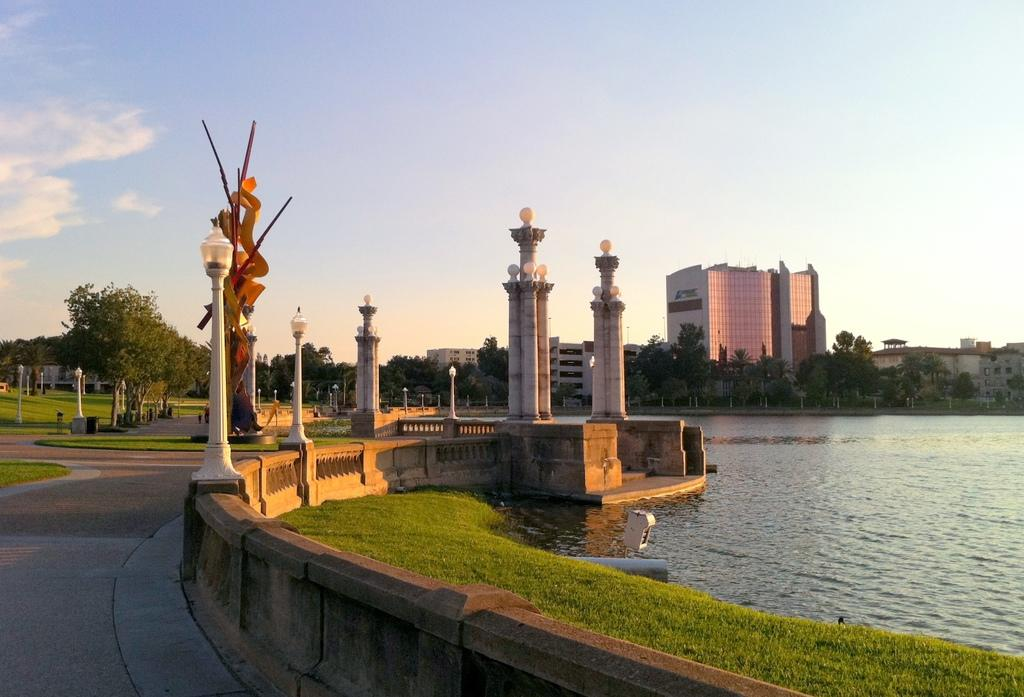What type of structures can be seen in the image? There are buildings in the image. What natural elements are present in the image? There are trees and grass on the ground in the image. What artificial elements are present in the image? There are poles with lights in the image. What type of surface is visible in the image? There is water visible in the image. How would you describe the sky in the image? The sky is blue and cloudy in the image. What additional feature can be found in the image? There is a statue in the image. How many buttons can be seen on the statue in the image? There are no buttons present on the statue in the image. What type of snails can be seen crawling on the grass in the image? There are no snails present in the image. 